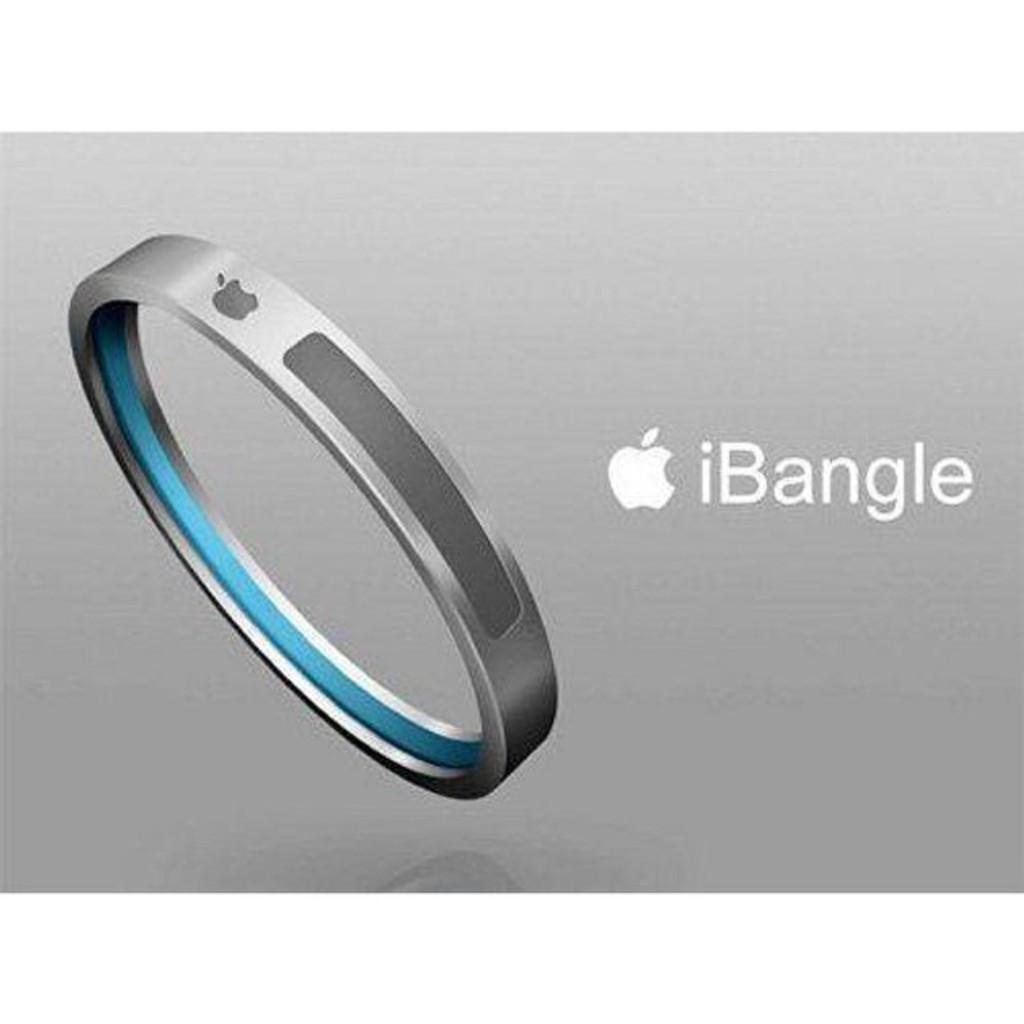<image>
Write a terse but informative summary of the picture. An Apple product that is designed to be worn on the wrist 